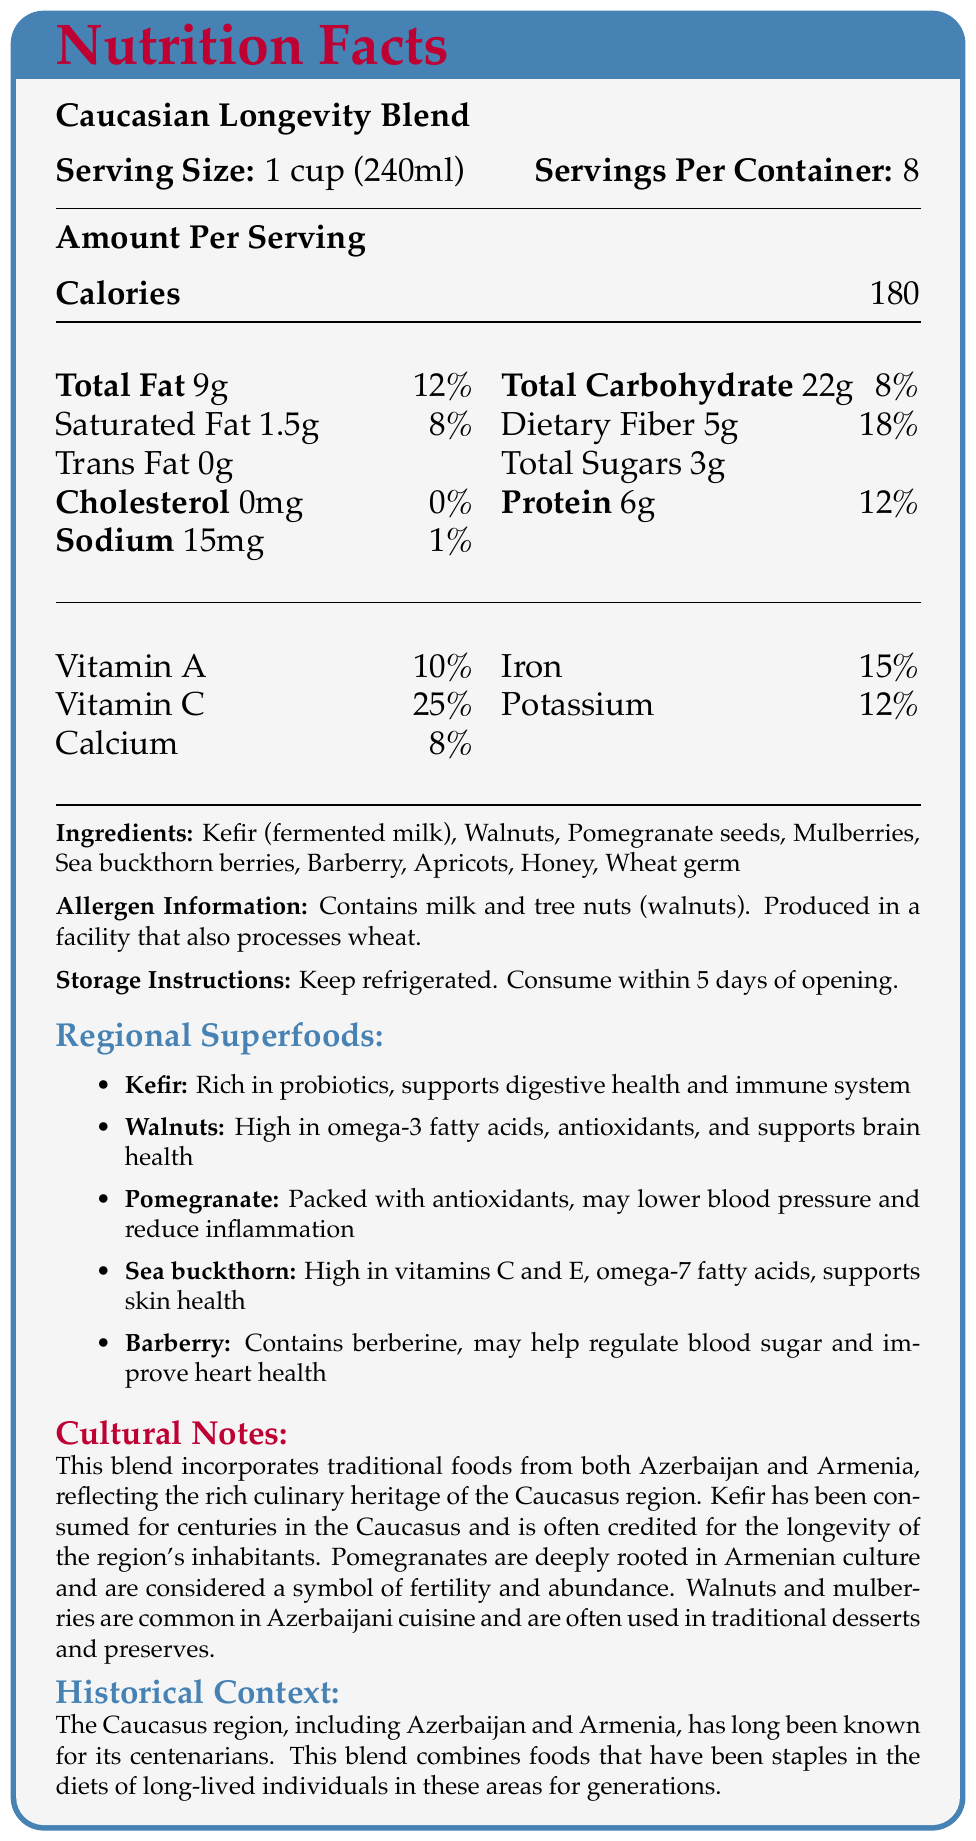how many servings are in one container? The document states "Servings Per Container: 8".
Answer: 8 what is the serving size? The document lists "Serving Size: 1 cup (240ml)".
Answer: 1 cup (240ml) what percentage of the daily value of protein does one serving provide? The document states that the protein content per serving is 6g, which represents 12% of the daily value.
Answer: 12% list two vitamins included in the Caucasian Longevity Blend and their daily value percentages. The document lists "Vitamin A 10%" and "Vitamin C 25%" under the nutrient breakdown.
Answer: Vitamin A – 10%, Vitamin C – 25% what are the main allergens present in the product? The document specifies "Contains milk and tree nuts (walnuts)" under allergen information.
Answer: Milk and tree nuts (walnuts) how many grams of dietary fiber are in one serving? The document lists "Dietary Fiber 5g" in the nutrient breakdown section.
Answer: 5g which of the following ingredients is NOT in the product? A. Sea buckthorn berries B. Kefir C. Almonds D. Honey The ingredients listed are Kefir, Walnuts, Pomegranate seeds, Mulberries, Sea buckthorn berries, Barberry, Apricots, Honey, Wheat germ. Almonds are not in the list.
Answer: C. Almonds which regional superfood is known for supporting brain health? A. Kefir B. Walnuts C. Barberry The document states "Walnuts: High in omega-3 fatty acids, antioxidants, and supports brain health".
Answer: B. Walnuts is cholesterol present in the product? The document states "Cholesterol: 0mg 0%" indicating there is no cholesterol.
Answer: No summarize the main idea of the document The document provides detailed nutritional information for Caucasian Longevity Blend, emphasizing its health benefits and cultural significance in the Caucasus region, specifically Azerbaijan and Armenia.
Answer: It is a nutritional facts label for a product called Caucasian Longevity Blend. The label includes serving size and number of servings, calorie content, break down of fats, cholesterol, sodium, carbohydrates, dietary fiber, sugars, protein, various vitamins and minerals information, allergen information, storage instructions, a list of ingredients, and additional cultural, historical, and regional superfoods notes. how many grams of sugar are in one serving? The document states "Total Sugars: 3g" in the nutrient information section.
Answer: 3g where should the product be stored after opening? The storage instructions specify "Keep refrigerated. Consume within 5 days of opening."
Answer: In the refrigerator which ingredient supports digestive health and the immune system? The document notes Kefir as "Rich in probiotics, supports digestive health and immune system."
Answer: Kefir what is the calorie count per serving? The document states "Calories: 180" per serving.
Answer: 180 what symbol deeply rooted in Armenian culture is associated with pomegranates? The cultural notes mention that pomegranates are considered a symbol of fertility and abundance in Armenian culture.
Answer: Fertility and abundance can we determine the manufacturing location from the document? The document does not provide information on the manufacturing location.
Answer: Not enough information 